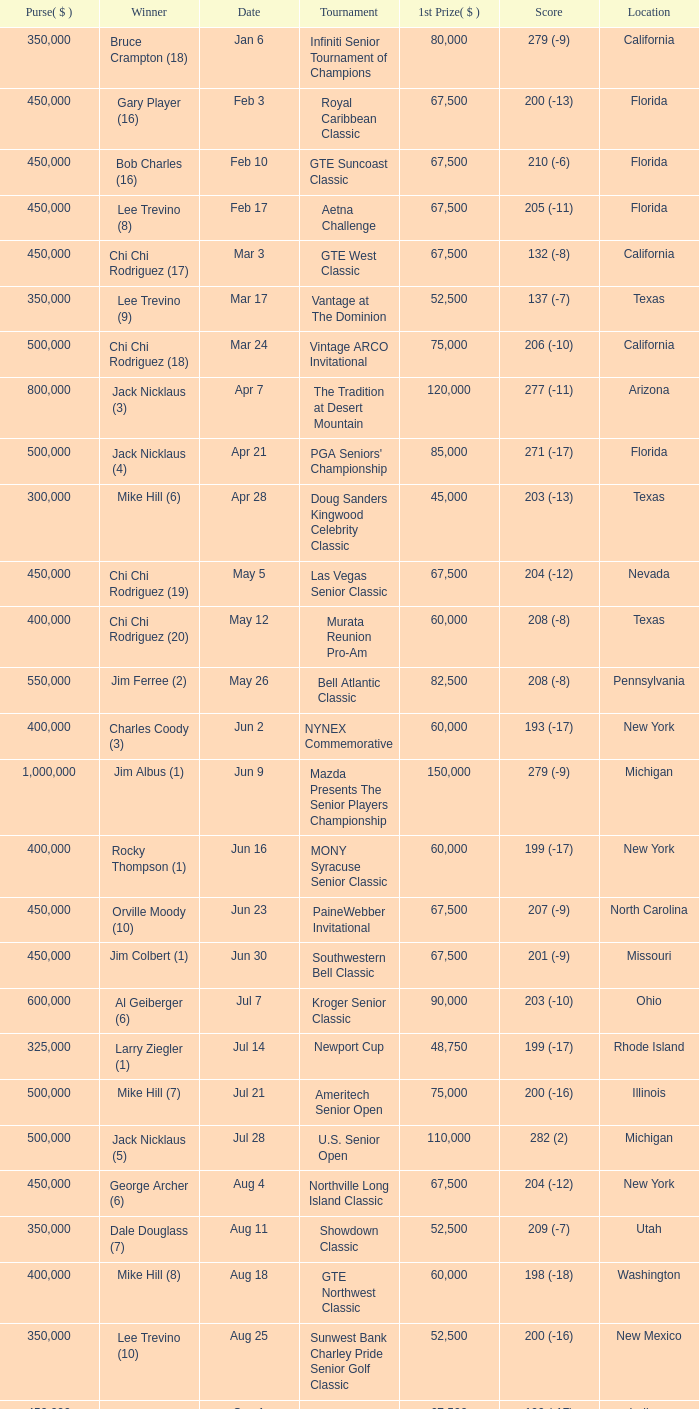What is the purse for the tournament with a winning score of 212 (-4), and a 1st prize of under $105,000? None. 